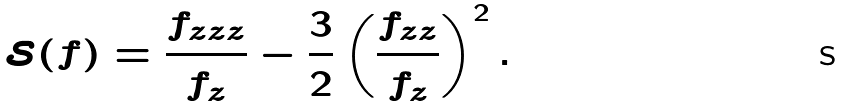<formula> <loc_0><loc_0><loc_500><loc_500>\mathcal { S } ( f ) = \frac { f _ { z z z } } { f _ { z } } - \frac { 3 } { 2 } \left ( \frac { f _ { z z } } { f _ { z } } \right ) ^ { 2 } .</formula> 